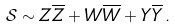<formula> <loc_0><loc_0><loc_500><loc_500>\mathcal { S } \sim Z \overline { Z } + W \overline { W } + Y \overline { Y } \, .</formula> 